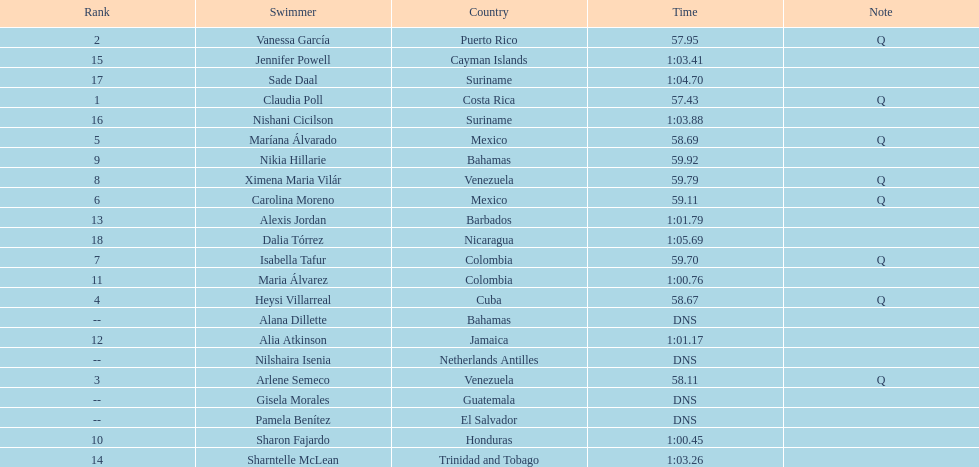How many competitors from venezuela qualified for the final? 2. 